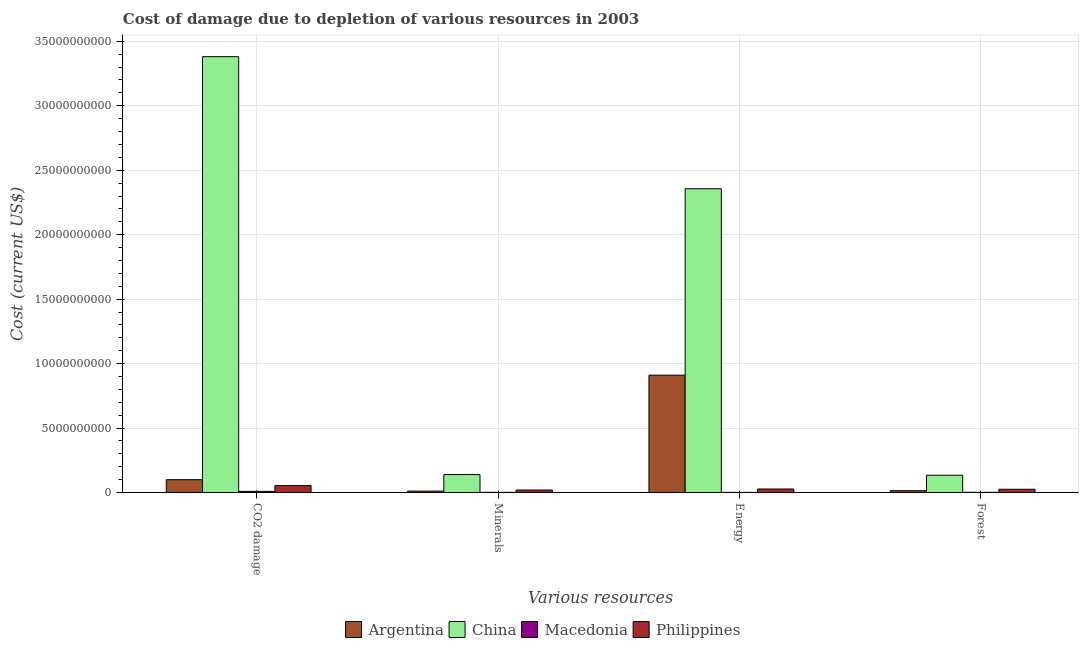How many groups of bars are there?
Your response must be concise. 4. How many bars are there on the 2nd tick from the left?
Provide a short and direct response. 4. What is the label of the 2nd group of bars from the left?
Your answer should be compact. Minerals. What is the cost of damage due to depletion of coal in Philippines?
Offer a terse response. 5.34e+08. Across all countries, what is the maximum cost of damage due to depletion of coal?
Provide a succinct answer. 3.38e+1. Across all countries, what is the minimum cost of damage due to depletion of energy?
Offer a very short reply. 8.05e+06. In which country was the cost of damage due to depletion of forests maximum?
Ensure brevity in your answer.  China. In which country was the cost of damage due to depletion of coal minimum?
Ensure brevity in your answer.  Macedonia. What is the total cost of damage due to depletion of energy in the graph?
Your response must be concise. 3.29e+1. What is the difference between the cost of damage due to depletion of coal in China and that in Macedonia?
Your answer should be very brief. 3.37e+1. What is the difference between the cost of damage due to depletion of minerals in Macedonia and the cost of damage due to depletion of energy in China?
Provide a short and direct response. -2.36e+1. What is the average cost of damage due to depletion of forests per country?
Your answer should be compact. 4.36e+08. What is the difference between the cost of damage due to depletion of energy and cost of damage due to depletion of forests in Argentina?
Your answer should be very brief. 8.96e+09. In how many countries, is the cost of damage due to depletion of forests greater than 23000000000 US$?
Provide a short and direct response. 0. What is the ratio of the cost of damage due to depletion of coal in Macedonia to that in Argentina?
Your response must be concise. 0.08. What is the difference between the highest and the second highest cost of damage due to depletion of coal?
Make the answer very short. 3.28e+1. What is the difference between the highest and the lowest cost of damage due to depletion of energy?
Your answer should be compact. 2.36e+1. In how many countries, is the cost of damage due to depletion of forests greater than the average cost of damage due to depletion of forests taken over all countries?
Keep it short and to the point. 1. Is it the case that in every country, the sum of the cost of damage due to depletion of coal and cost of damage due to depletion of minerals is greater than the sum of cost of damage due to depletion of energy and cost of damage due to depletion of forests?
Offer a terse response. No. What does the 1st bar from the right in CO2 damage represents?
Ensure brevity in your answer.  Philippines. How many legend labels are there?
Provide a succinct answer. 4. What is the title of the graph?
Offer a very short reply. Cost of damage due to depletion of various resources in 2003 . Does "Gabon" appear as one of the legend labels in the graph?
Give a very brief answer. No. What is the label or title of the X-axis?
Offer a terse response. Various resources. What is the label or title of the Y-axis?
Offer a very short reply. Cost (current US$). What is the Cost (current US$) of Argentina in CO2 damage?
Ensure brevity in your answer.  9.95e+08. What is the Cost (current US$) in China in CO2 damage?
Make the answer very short. 3.38e+1. What is the Cost (current US$) of Macedonia in CO2 damage?
Offer a very short reply. 8.45e+07. What is the Cost (current US$) of Philippines in CO2 damage?
Your answer should be very brief. 5.34e+08. What is the Cost (current US$) in Argentina in Minerals?
Make the answer very short. 1.08e+08. What is the Cost (current US$) in China in Minerals?
Make the answer very short. 1.39e+09. What is the Cost (current US$) of Macedonia in Minerals?
Provide a short and direct response. 1.19e+07. What is the Cost (current US$) of Philippines in Minerals?
Make the answer very short. 1.91e+08. What is the Cost (current US$) in Argentina in Energy?
Provide a short and direct response. 9.10e+09. What is the Cost (current US$) of China in Energy?
Offer a terse response. 2.36e+1. What is the Cost (current US$) in Macedonia in Energy?
Your response must be concise. 8.05e+06. What is the Cost (current US$) in Philippines in Energy?
Give a very brief answer. 2.70e+08. What is the Cost (current US$) in Argentina in Forest?
Offer a terse response. 1.40e+08. What is the Cost (current US$) in China in Forest?
Keep it short and to the point. 1.34e+09. What is the Cost (current US$) in Macedonia in Forest?
Ensure brevity in your answer.  1.35e+07. What is the Cost (current US$) in Philippines in Forest?
Ensure brevity in your answer.  2.50e+08. Across all Various resources, what is the maximum Cost (current US$) of Argentina?
Offer a terse response. 9.10e+09. Across all Various resources, what is the maximum Cost (current US$) of China?
Give a very brief answer. 3.38e+1. Across all Various resources, what is the maximum Cost (current US$) of Macedonia?
Provide a short and direct response. 8.45e+07. Across all Various resources, what is the maximum Cost (current US$) in Philippines?
Give a very brief answer. 5.34e+08. Across all Various resources, what is the minimum Cost (current US$) in Argentina?
Provide a short and direct response. 1.08e+08. Across all Various resources, what is the minimum Cost (current US$) in China?
Make the answer very short. 1.34e+09. Across all Various resources, what is the minimum Cost (current US$) of Macedonia?
Your response must be concise. 8.05e+06. Across all Various resources, what is the minimum Cost (current US$) of Philippines?
Your response must be concise. 1.91e+08. What is the total Cost (current US$) of Argentina in the graph?
Your answer should be very brief. 1.03e+1. What is the total Cost (current US$) of China in the graph?
Provide a short and direct response. 6.01e+1. What is the total Cost (current US$) in Macedonia in the graph?
Give a very brief answer. 1.18e+08. What is the total Cost (current US$) of Philippines in the graph?
Keep it short and to the point. 1.25e+09. What is the difference between the Cost (current US$) in Argentina in CO2 damage and that in Minerals?
Provide a succinct answer. 8.86e+08. What is the difference between the Cost (current US$) in China in CO2 damage and that in Minerals?
Make the answer very short. 3.24e+1. What is the difference between the Cost (current US$) of Macedonia in CO2 damage and that in Minerals?
Make the answer very short. 7.26e+07. What is the difference between the Cost (current US$) in Philippines in CO2 damage and that in Minerals?
Your answer should be very brief. 3.43e+08. What is the difference between the Cost (current US$) of Argentina in CO2 damage and that in Energy?
Your answer should be very brief. -8.11e+09. What is the difference between the Cost (current US$) of China in CO2 damage and that in Energy?
Provide a succinct answer. 1.02e+1. What is the difference between the Cost (current US$) in Macedonia in CO2 damage and that in Energy?
Provide a succinct answer. 7.64e+07. What is the difference between the Cost (current US$) in Philippines in CO2 damage and that in Energy?
Provide a succinct answer. 2.64e+08. What is the difference between the Cost (current US$) in Argentina in CO2 damage and that in Forest?
Ensure brevity in your answer.  8.54e+08. What is the difference between the Cost (current US$) of China in CO2 damage and that in Forest?
Provide a succinct answer. 3.25e+1. What is the difference between the Cost (current US$) of Macedonia in CO2 damage and that in Forest?
Your response must be concise. 7.10e+07. What is the difference between the Cost (current US$) in Philippines in CO2 damage and that in Forest?
Ensure brevity in your answer.  2.84e+08. What is the difference between the Cost (current US$) in Argentina in Minerals and that in Energy?
Your response must be concise. -8.99e+09. What is the difference between the Cost (current US$) in China in Minerals and that in Energy?
Give a very brief answer. -2.22e+1. What is the difference between the Cost (current US$) in Macedonia in Minerals and that in Energy?
Your answer should be compact. 3.86e+06. What is the difference between the Cost (current US$) in Philippines in Minerals and that in Energy?
Offer a terse response. -7.91e+07. What is the difference between the Cost (current US$) in Argentina in Minerals and that in Forest?
Keep it short and to the point. -3.19e+07. What is the difference between the Cost (current US$) in China in Minerals and that in Forest?
Offer a very short reply. 4.92e+07. What is the difference between the Cost (current US$) in Macedonia in Minerals and that in Forest?
Make the answer very short. -1.62e+06. What is the difference between the Cost (current US$) of Philippines in Minerals and that in Forest?
Make the answer very short. -5.92e+07. What is the difference between the Cost (current US$) in Argentina in Energy and that in Forest?
Your response must be concise. 8.96e+09. What is the difference between the Cost (current US$) of China in Energy and that in Forest?
Ensure brevity in your answer.  2.22e+1. What is the difference between the Cost (current US$) in Macedonia in Energy and that in Forest?
Give a very brief answer. -5.48e+06. What is the difference between the Cost (current US$) of Philippines in Energy and that in Forest?
Offer a terse response. 1.98e+07. What is the difference between the Cost (current US$) in Argentina in CO2 damage and the Cost (current US$) in China in Minerals?
Give a very brief answer. -3.96e+08. What is the difference between the Cost (current US$) of Argentina in CO2 damage and the Cost (current US$) of Macedonia in Minerals?
Provide a short and direct response. 9.83e+08. What is the difference between the Cost (current US$) in Argentina in CO2 damage and the Cost (current US$) in Philippines in Minerals?
Your answer should be compact. 8.04e+08. What is the difference between the Cost (current US$) in China in CO2 damage and the Cost (current US$) in Macedonia in Minerals?
Keep it short and to the point. 3.38e+1. What is the difference between the Cost (current US$) of China in CO2 damage and the Cost (current US$) of Philippines in Minerals?
Your answer should be very brief. 3.36e+1. What is the difference between the Cost (current US$) of Macedonia in CO2 damage and the Cost (current US$) of Philippines in Minerals?
Ensure brevity in your answer.  -1.07e+08. What is the difference between the Cost (current US$) of Argentina in CO2 damage and the Cost (current US$) of China in Energy?
Give a very brief answer. -2.26e+1. What is the difference between the Cost (current US$) of Argentina in CO2 damage and the Cost (current US$) of Macedonia in Energy?
Your answer should be compact. 9.87e+08. What is the difference between the Cost (current US$) in Argentina in CO2 damage and the Cost (current US$) in Philippines in Energy?
Your answer should be compact. 7.24e+08. What is the difference between the Cost (current US$) of China in CO2 damage and the Cost (current US$) of Macedonia in Energy?
Give a very brief answer. 3.38e+1. What is the difference between the Cost (current US$) in China in CO2 damage and the Cost (current US$) in Philippines in Energy?
Give a very brief answer. 3.35e+1. What is the difference between the Cost (current US$) of Macedonia in CO2 damage and the Cost (current US$) of Philippines in Energy?
Provide a succinct answer. -1.86e+08. What is the difference between the Cost (current US$) of Argentina in CO2 damage and the Cost (current US$) of China in Forest?
Your response must be concise. -3.47e+08. What is the difference between the Cost (current US$) of Argentina in CO2 damage and the Cost (current US$) of Macedonia in Forest?
Make the answer very short. 9.81e+08. What is the difference between the Cost (current US$) of Argentina in CO2 damage and the Cost (current US$) of Philippines in Forest?
Your answer should be very brief. 7.44e+08. What is the difference between the Cost (current US$) of China in CO2 damage and the Cost (current US$) of Macedonia in Forest?
Provide a short and direct response. 3.38e+1. What is the difference between the Cost (current US$) in China in CO2 damage and the Cost (current US$) in Philippines in Forest?
Give a very brief answer. 3.36e+1. What is the difference between the Cost (current US$) of Macedonia in CO2 damage and the Cost (current US$) of Philippines in Forest?
Your answer should be very brief. -1.66e+08. What is the difference between the Cost (current US$) of Argentina in Minerals and the Cost (current US$) of China in Energy?
Your answer should be very brief. -2.35e+1. What is the difference between the Cost (current US$) of Argentina in Minerals and the Cost (current US$) of Macedonia in Energy?
Offer a terse response. 1.00e+08. What is the difference between the Cost (current US$) of Argentina in Minerals and the Cost (current US$) of Philippines in Energy?
Keep it short and to the point. -1.62e+08. What is the difference between the Cost (current US$) in China in Minerals and the Cost (current US$) in Macedonia in Energy?
Offer a terse response. 1.38e+09. What is the difference between the Cost (current US$) of China in Minerals and the Cost (current US$) of Philippines in Energy?
Provide a short and direct response. 1.12e+09. What is the difference between the Cost (current US$) of Macedonia in Minerals and the Cost (current US$) of Philippines in Energy?
Your answer should be compact. -2.58e+08. What is the difference between the Cost (current US$) of Argentina in Minerals and the Cost (current US$) of China in Forest?
Provide a short and direct response. -1.23e+09. What is the difference between the Cost (current US$) of Argentina in Minerals and the Cost (current US$) of Macedonia in Forest?
Ensure brevity in your answer.  9.48e+07. What is the difference between the Cost (current US$) of Argentina in Minerals and the Cost (current US$) of Philippines in Forest?
Your answer should be very brief. -1.42e+08. What is the difference between the Cost (current US$) of China in Minerals and the Cost (current US$) of Macedonia in Forest?
Give a very brief answer. 1.38e+09. What is the difference between the Cost (current US$) of China in Minerals and the Cost (current US$) of Philippines in Forest?
Provide a short and direct response. 1.14e+09. What is the difference between the Cost (current US$) in Macedonia in Minerals and the Cost (current US$) in Philippines in Forest?
Keep it short and to the point. -2.38e+08. What is the difference between the Cost (current US$) in Argentina in Energy and the Cost (current US$) in China in Forest?
Provide a succinct answer. 7.76e+09. What is the difference between the Cost (current US$) in Argentina in Energy and the Cost (current US$) in Macedonia in Forest?
Offer a terse response. 9.09e+09. What is the difference between the Cost (current US$) of Argentina in Energy and the Cost (current US$) of Philippines in Forest?
Your answer should be compact. 8.85e+09. What is the difference between the Cost (current US$) in China in Energy and the Cost (current US$) in Macedonia in Forest?
Provide a short and direct response. 2.35e+1. What is the difference between the Cost (current US$) of China in Energy and the Cost (current US$) of Philippines in Forest?
Your response must be concise. 2.33e+1. What is the difference between the Cost (current US$) in Macedonia in Energy and the Cost (current US$) in Philippines in Forest?
Keep it short and to the point. -2.42e+08. What is the average Cost (current US$) of Argentina per Various resources?
Offer a terse response. 2.59e+09. What is the average Cost (current US$) of China per Various resources?
Provide a short and direct response. 1.50e+1. What is the average Cost (current US$) in Macedonia per Various resources?
Your answer should be very brief. 2.95e+07. What is the average Cost (current US$) in Philippines per Various resources?
Your answer should be very brief. 3.12e+08. What is the difference between the Cost (current US$) of Argentina and Cost (current US$) of China in CO2 damage?
Keep it short and to the point. -3.28e+1. What is the difference between the Cost (current US$) of Argentina and Cost (current US$) of Macedonia in CO2 damage?
Your response must be concise. 9.10e+08. What is the difference between the Cost (current US$) in Argentina and Cost (current US$) in Philippines in CO2 damage?
Offer a terse response. 4.60e+08. What is the difference between the Cost (current US$) of China and Cost (current US$) of Macedonia in CO2 damage?
Make the answer very short. 3.37e+1. What is the difference between the Cost (current US$) in China and Cost (current US$) in Philippines in CO2 damage?
Your answer should be compact. 3.33e+1. What is the difference between the Cost (current US$) in Macedonia and Cost (current US$) in Philippines in CO2 damage?
Provide a short and direct response. -4.50e+08. What is the difference between the Cost (current US$) of Argentina and Cost (current US$) of China in Minerals?
Your answer should be very brief. -1.28e+09. What is the difference between the Cost (current US$) of Argentina and Cost (current US$) of Macedonia in Minerals?
Ensure brevity in your answer.  9.64e+07. What is the difference between the Cost (current US$) in Argentina and Cost (current US$) in Philippines in Minerals?
Provide a short and direct response. -8.28e+07. What is the difference between the Cost (current US$) of China and Cost (current US$) of Macedonia in Minerals?
Ensure brevity in your answer.  1.38e+09. What is the difference between the Cost (current US$) in China and Cost (current US$) in Philippines in Minerals?
Keep it short and to the point. 1.20e+09. What is the difference between the Cost (current US$) of Macedonia and Cost (current US$) of Philippines in Minerals?
Provide a succinct answer. -1.79e+08. What is the difference between the Cost (current US$) in Argentina and Cost (current US$) in China in Energy?
Your response must be concise. -1.45e+1. What is the difference between the Cost (current US$) of Argentina and Cost (current US$) of Macedonia in Energy?
Give a very brief answer. 9.09e+09. What is the difference between the Cost (current US$) of Argentina and Cost (current US$) of Philippines in Energy?
Keep it short and to the point. 8.83e+09. What is the difference between the Cost (current US$) in China and Cost (current US$) in Macedonia in Energy?
Your answer should be very brief. 2.36e+1. What is the difference between the Cost (current US$) in China and Cost (current US$) in Philippines in Energy?
Your answer should be very brief. 2.33e+1. What is the difference between the Cost (current US$) of Macedonia and Cost (current US$) of Philippines in Energy?
Ensure brevity in your answer.  -2.62e+08. What is the difference between the Cost (current US$) in Argentina and Cost (current US$) in China in Forest?
Your response must be concise. -1.20e+09. What is the difference between the Cost (current US$) in Argentina and Cost (current US$) in Macedonia in Forest?
Your response must be concise. 1.27e+08. What is the difference between the Cost (current US$) of Argentina and Cost (current US$) of Philippines in Forest?
Make the answer very short. -1.10e+08. What is the difference between the Cost (current US$) of China and Cost (current US$) of Macedonia in Forest?
Your answer should be compact. 1.33e+09. What is the difference between the Cost (current US$) in China and Cost (current US$) in Philippines in Forest?
Give a very brief answer. 1.09e+09. What is the difference between the Cost (current US$) of Macedonia and Cost (current US$) of Philippines in Forest?
Ensure brevity in your answer.  -2.37e+08. What is the ratio of the Cost (current US$) in Argentina in CO2 damage to that in Minerals?
Keep it short and to the point. 9.18. What is the ratio of the Cost (current US$) in China in CO2 damage to that in Minerals?
Your answer should be compact. 24.31. What is the ratio of the Cost (current US$) of Macedonia in CO2 damage to that in Minerals?
Provide a succinct answer. 7.1. What is the ratio of the Cost (current US$) in Philippines in CO2 damage to that in Minerals?
Your answer should be very brief. 2.8. What is the ratio of the Cost (current US$) in Argentina in CO2 damage to that in Energy?
Your answer should be compact. 0.11. What is the ratio of the Cost (current US$) of China in CO2 damage to that in Energy?
Provide a short and direct response. 1.43. What is the ratio of the Cost (current US$) in Macedonia in CO2 damage to that in Energy?
Your answer should be very brief. 10.5. What is the ratio of the Cost (current US$) of Philippines in CO2 damage to that in Energy?
Your answer should be compact. 1.98. What is the ratio of the Cost (current US$) in Argentina in CO2 damage to that in Forest?
Make the answer very short. 7.09. What is the ratio of the Cost (current US$) in China in CO2 damage to that in Forest?
Your response must be concise. 25.2. What is the ratio of the Cost (current US$) of Macedonia in CO2 damage to that in Forest?
Offer a very short reply. 6.25. What is the ratio of the Cost (current US$) in Philippines in CO2 damage to that in Forest?
Your response must be concise. 2.13. What is the ratio of the Cost (current US$) of Argentina in Minerals to that in Energy?
Ensure brevity in your answer.  0.01. What is the ratio of the Cost (current US$) in China in Minerals to that in Energy?
Ensure brevity in your answer.  0.06. What is the ratio of the Cost (current US$) in Macedonia in Minerals to that in Energy?
Keep it short and to the point. 1.48. What is the ratio of the Cost (current US$) of Philippines in Minerals to that in Energy?
Keep it short and to the point. 0.71. What is the ratio of the Cost (current US$) of Argentina in Minerals to that in Forest?
Ensure brevity in your answer.  0.77. What is the ratio of the Cost (current US$) of China in Minerals to that in Forest?
Provide a short and direct response. 1.04. What is the ratio of the Cost (current US$) in Macedonia in Minerals to that in Forest?
Keep it short and to the point. 0.88. What is the ratio of the Cost (current US$) of Philippines in Minerals to that in Forest?
Your response must be concise. 0.76. What is the ratio of the Cost (current US$) in Argentina in Energy to that in Forest?
Provide a succinct answer. 64.87. What is the ratio of the Cost (current US$) of China in Energy to that in Forest?
Offer a very short reply. 17.56. What is the ratio of the Cost (current US$) in Macedonia in Energy to that in Forest?
Your answer should be very brief. 0.59. What is the ratio of the Cost (current US$) in Philippines in Energy to that in Forest?
Keep it short and to the point. 1.08. What is the difference between the highest and the second highest Cost (current US$) of Argentina?
Give a very brief answer. 8.11e+09. What is the difference between the highest and the second highest Cost (current US$) in China?
Give a very brief answer. 1.02e+1. What is the difference between the highest and the second highest Cost (current US$) of Macedonia?
Offer a very short reply. 7.10e+07. What is the difference between the highest and the second highest Cost (current US$) in Philippines?
Your response must be concise. 2.64e+08. What is the difference between the highest and the lowest Cost (current US$) of Argentina?
Give a very brief answer. 8.99e+09. What is the difference between the highest and the lowest Cost (current US$) of China?
Keep it short and to the point. 3.25e+1. What is the difference between the highest and the lowest Cost (current US$) in Macedonia?
Your answer should be very brief. 7.64e+07. What is the difference between the highest and the lowest Cost (current US$) of Philippines?
Your answer should be very brief. 3.43e+08. 